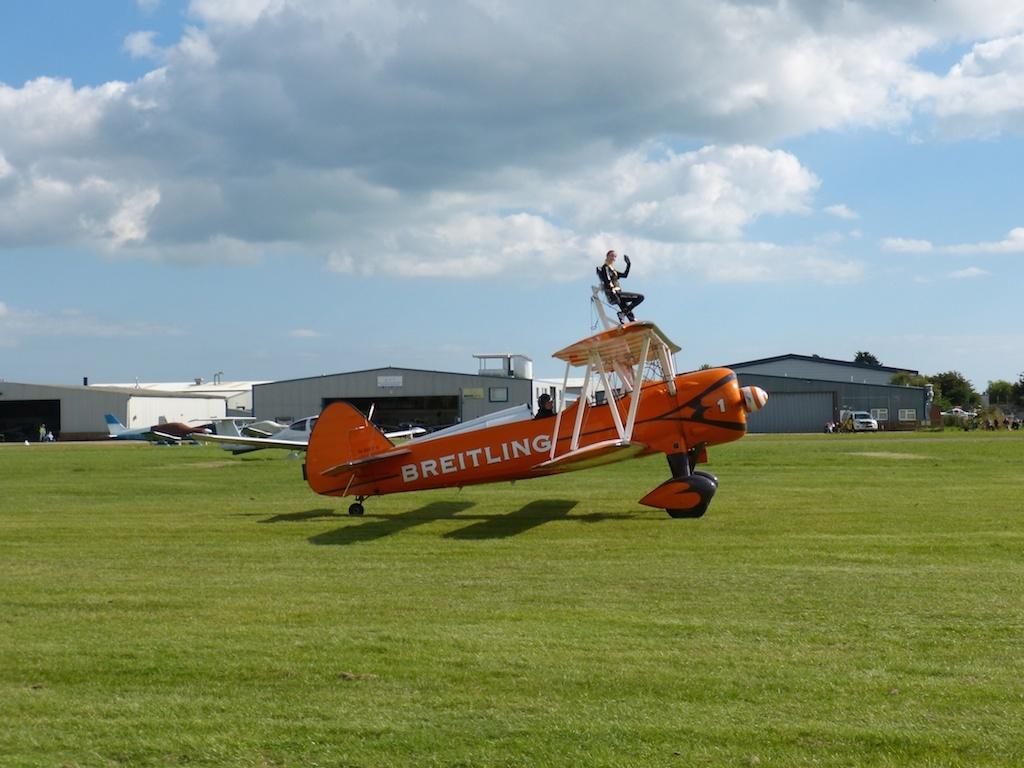What brand is the plane?
Give a very brief answer. Breitling. 